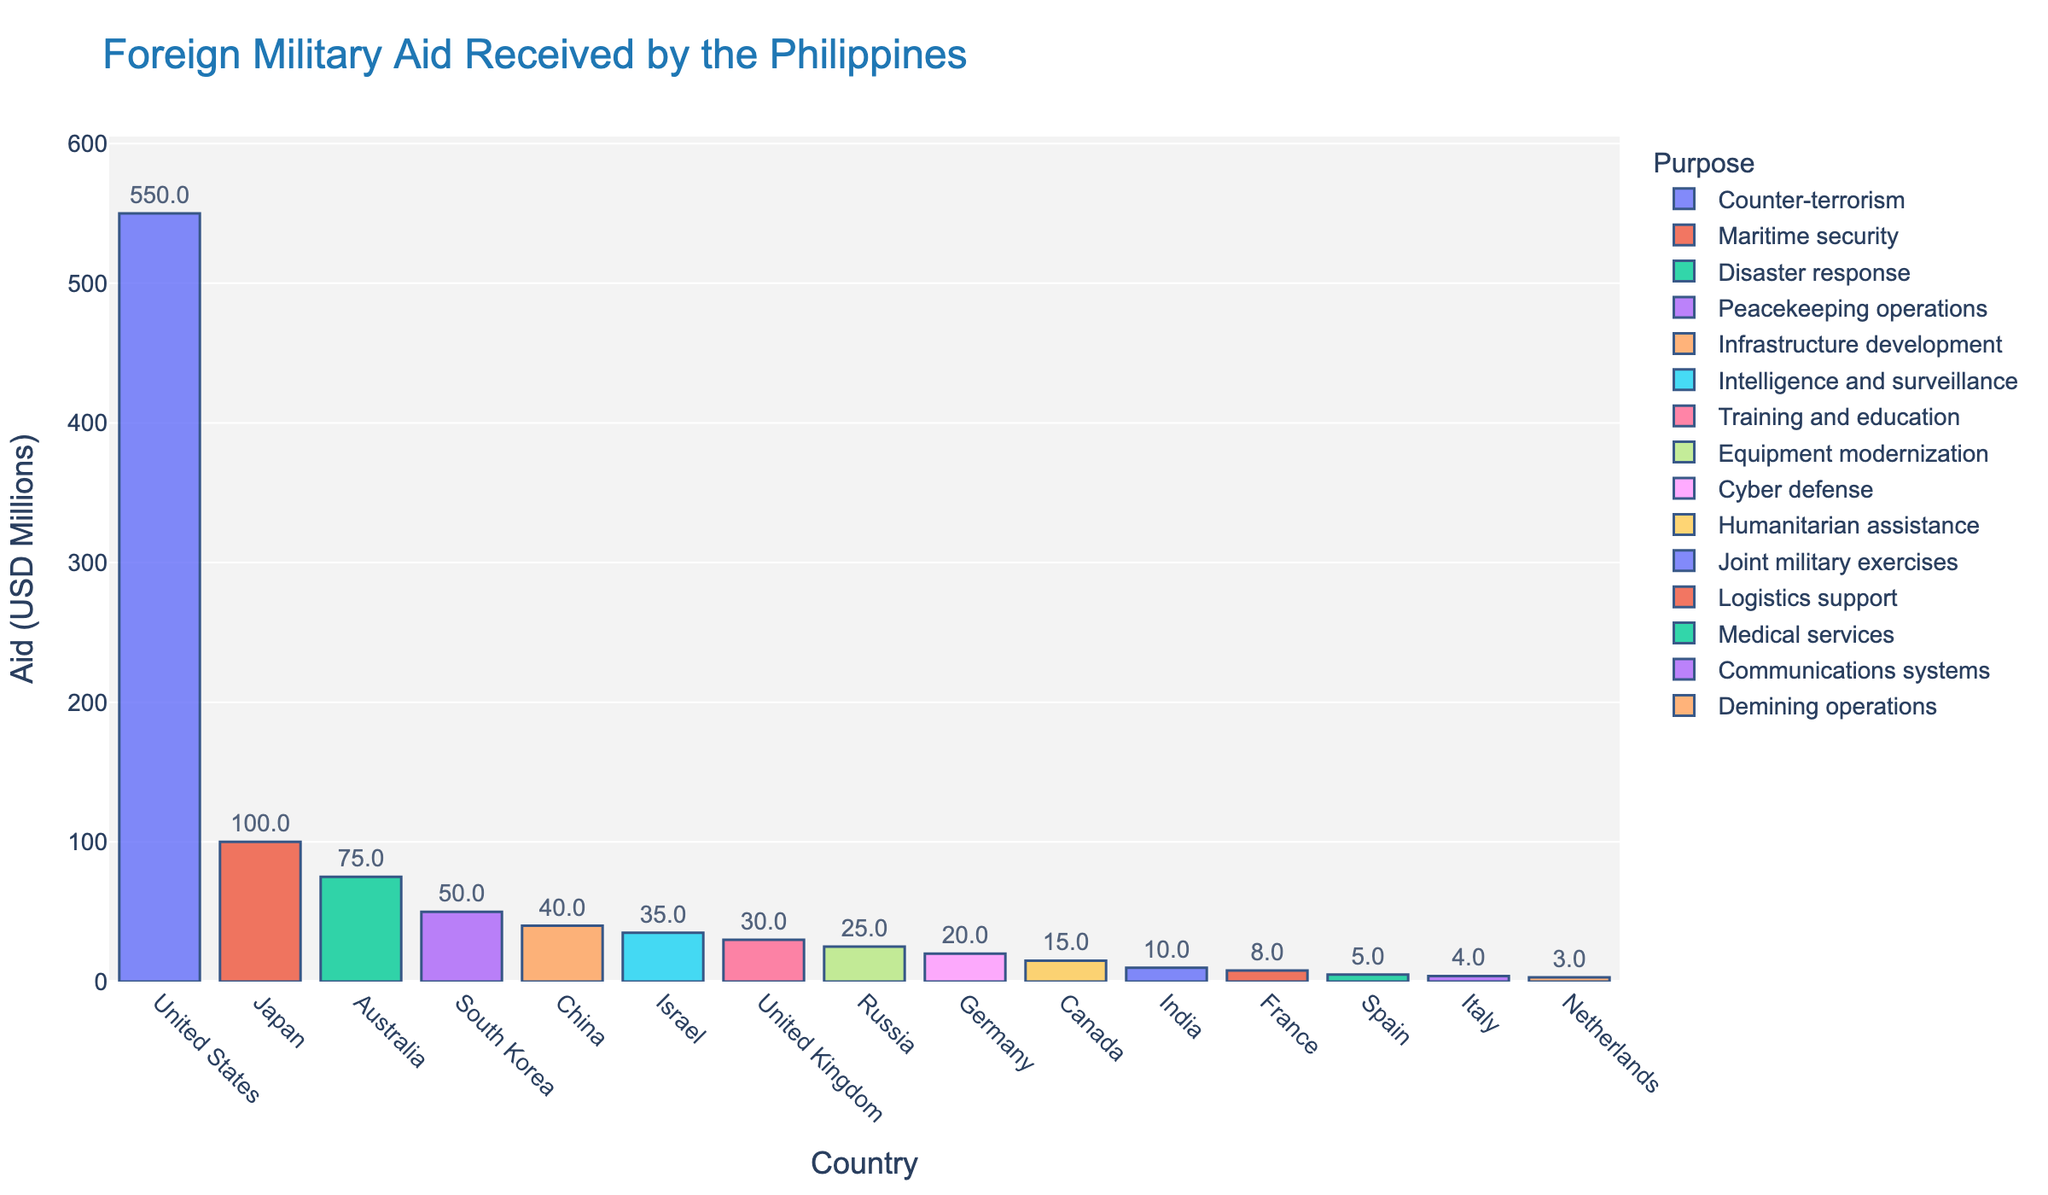Which country provided the highest amount of military aid? By observing the height of the bars on the figure, we can see that the United States provided the highest amount of military aid at 550 USD million.
Answer: United States Which two countries provided similar amounts of military aid? By comparing the heights of the bars, Israel and the United Kingdom provided similar amounts of military aid, with 35 and 30 USD million respectively.
Answer: Israel and United Kingdom What is the total military aid provided by Japan and Australia? The military aid provided by Japan is 100 USD million and by Australia is 75 USD million. Summing them up, 100 + 75 = 175 USD million.
Answer: 175 USD million How many countries provided military aid specifically for counter-terrorism? By examining the color representation of the bars in the figure, only the bar for the United States, marked at 550 USD million, represents aid for counter-terrorism.
Answer: One Which country provided more aid for peacekeeping operations, South Korea or Russia? Comparing the heights of the bars of South Korea and Russia, we see that South Korea provided more aid at 50 USD million whereas Russia provided 25 USD million.
Answer: South Korea What is the combined military aid from the top three donor countries? The top three donor countries are the United States (550 USD million), Japan (100 USD million), and Australia (75 USD million). Summing these up, 550 + 100 + 75 = 725 USD million.
Answer: 725 USD million How does the aid provided by Canada for humanitarian assistance compare to the aid provided by China for infrastructure development? Comparing the heights of the bars of Canada and China, we see that China provided more aid at 40 USD million, whereas Canada provided 15 USD million.
Answer: China provided more Which purpose received the least amount of aid and which country provided it? By inspecting the bars with the smallest height, we find that the Netherlands provided the least amount of aid at 3 USD million for demining operations.
Answer: Netherlands Sum the aid provided by South Korea, Israel, and Germany. South Korea (50 USD million), Israel (35 USD million), and Germany (20 USD million). Summing them up, 50 + 35 + 20 = 105 USD million.
Answer: 105 USD million What is the average military aid provided by European countries listed in the data? The European countries listed are the United Kingdom (30 USD million), Germany (20 USD million), France (8 USD million), Spain (5 USD million), Italy (4 USD million), Netherlands (3 USD million). The total aid is 30 + 20 + 8 + 5 + 4 + 3 = 70 USD million from 6 countries. The average is 70 / 6 ≈ 11.67 USD million.
Answer: 11.67 USD million 